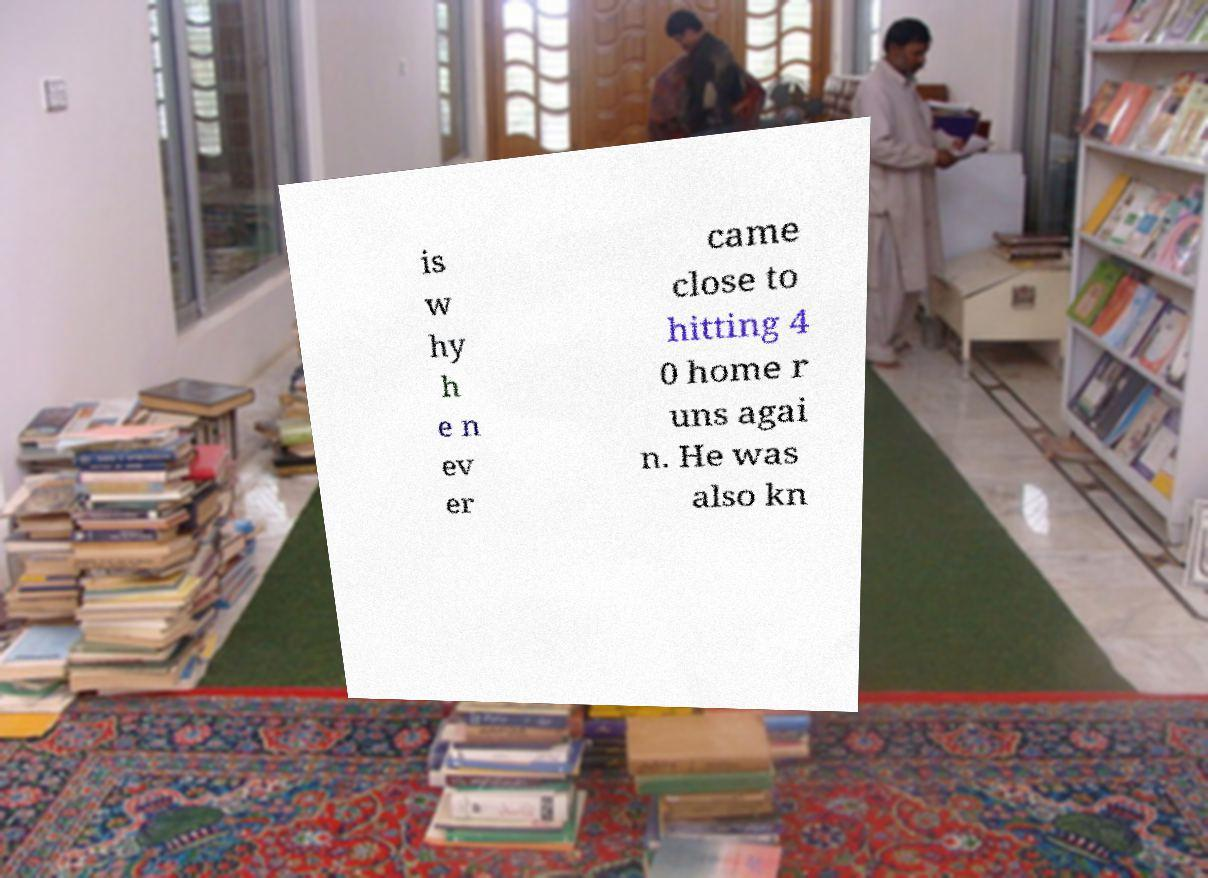There's text embedded in this image that I need extracted. Can you transcribe it verbatim? is w hy h e n ev er came close to hitting 4 0 home r uns agai n. He was also kn 